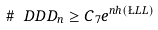<formula> <loc_0><loc_0><loc_500><loc_500>\# \ D D D _ { n } \geq C _ { 7 } e ^ { n h ( \L L L ) }</formula> 